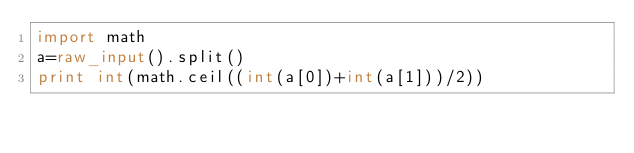Convert code to text. <code><loc_0><loc_0><loc_500><loc_500><_Python_>import math
a=raw_input().split()
print int(math.ceil((int(a[0])+int(a[1]))/2))</code> 